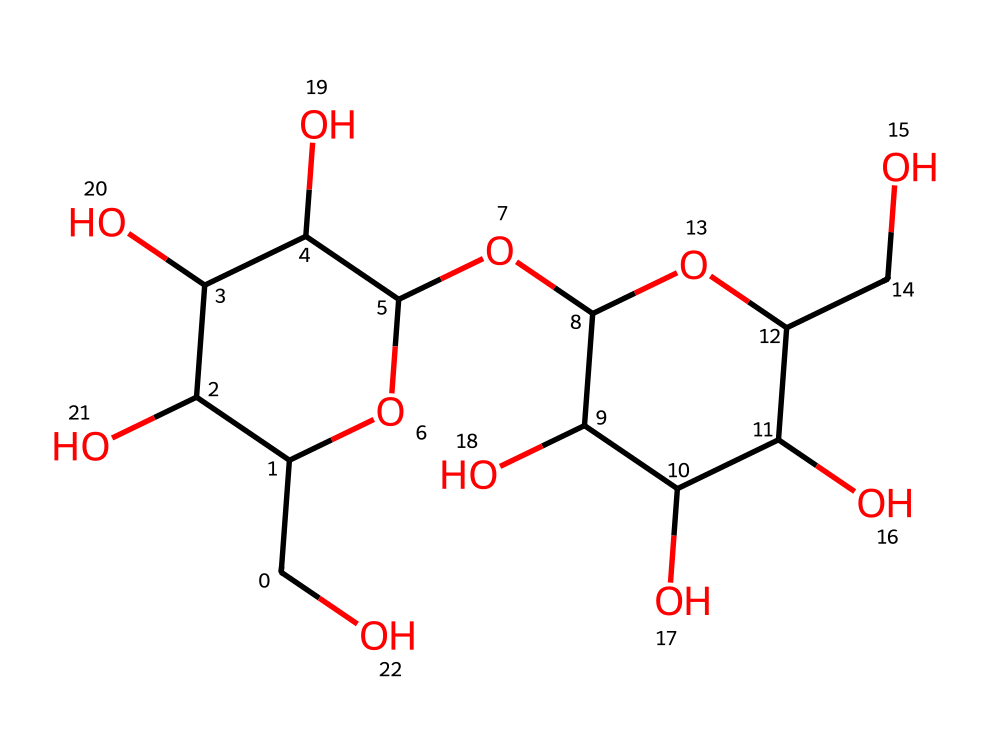what is the total number of carbon atoms in this structure? To find the total number of carbon atoms, I examine the SMILES representation to count each 'C'. After parsing the structure, I can see there are 12 carbon atoms in total.
Answer: twelve what type of solid does sucrose form in its crystalline structure? Sucrose, being a sugar, forms molecular crystals due to its non-ionic and covalent nature, resulting in a solid structure typical of organic compounds.
Answer: molecular how many hydroxyl groups are present in this compound? By analyzing the molecule, I identify hydroxyl groups represented by the 'O' connected to 'H'. There are six hydroxyl groups in total in the structure.
Answer: six what is the major type of bonding found in sucrose crystals? The predominant bonding in the crystalline structure of sucrose is covalent bonding, which occurs between the atoms within the sugar molecule, resulting in a stable solid state.
Answer: covalent how does the crystal structure of sucrose influence its taste? The arrangement of atoms in the solid state of sucrose allows it to be sweet due to the molecular interactions perceived by taste receptors. The specific orientation in the crystalline structure efficiently binds to sweetness receptors.
Answer: sweet what is the molecular weight of sucrose? The molecular weight can be calculated based on the number of atoms present in the chemical structure. For sucrose, the molecular formula is C12H22O11, which gives it a molecular weight of approximately 342.3 g/mol.
Answer: 342.3 what is the melting point range for sucrose as a crystalline solid? Sucrose as a crystalline solid typically melts at a range of around 160 to 186 degrees Celsius, where it undergoes changes before caramelizing. The precise range influences its culinary applications in dishes.
Answer: 160 to 186 